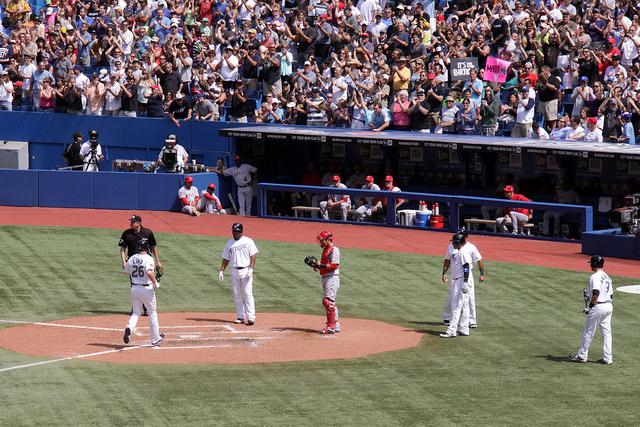Is this a sold-out game?
Keep it brief. Yes. Are there any fans here?
Write a very short answer. Yes. What sport is being played?
Concise answer only. Baseball. The team players are wearing what color running shoes?
Keep it brief. White. 